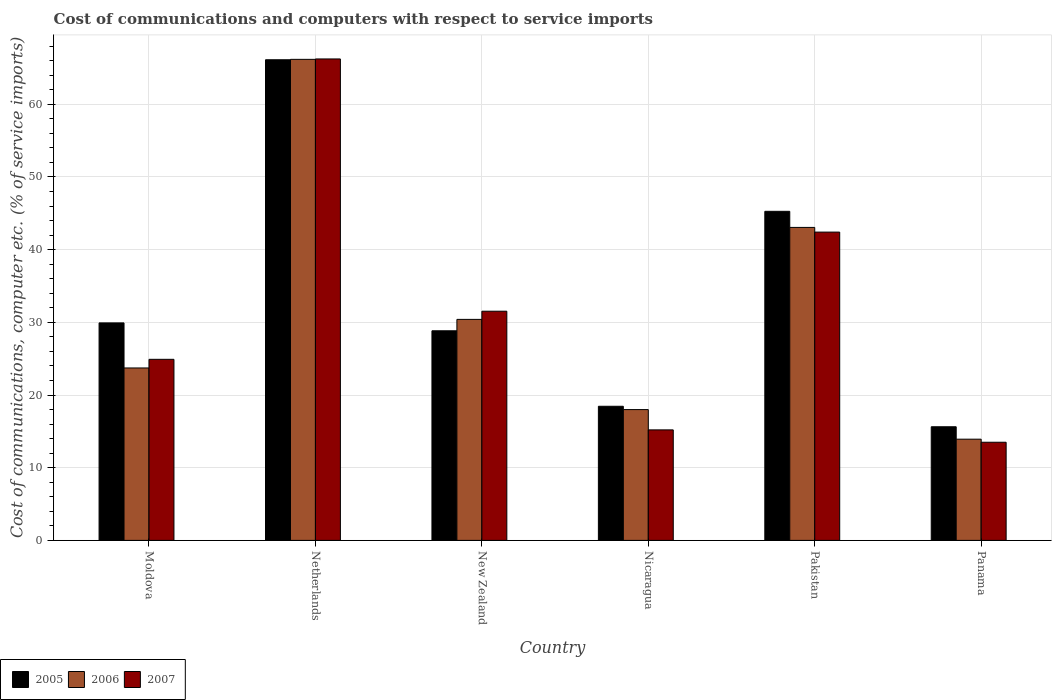Are the number of bars per tick equal to the number of legend labels?
Keep it short and to the point. Yes. Are the number of bars on each tick of the X-axis equal?
Give a very brief answer. Yes. How many bars are there on the 4th tick from the left?
Make the answer very short. 3. How many bars are there on the 4th tick from the right?
Your answer should be compact. 3. In how many cases, is the number of bars for a given country not equal to the number of legend labels?
Provide a short and direct response. 0. What is the cost of communications and computers in 2007 in Moldova?
Keep it short and to the point. 24.91. Across all countries, what is the maximum cost of communications and computers in 2005?
Ensure brevity in your answer.  66.12. Across all countries, what is the minimum cost of communications and computers in 2007?
Ensure brevity in your answer.  13.5. In which country was the cost of communications and computers in 2005 minimum?
Keep it short and to the point. Panama. What is the total cost of communications and computers in 2006 in the graph?
Give a very brief answer. 195.28. What is the difference between the cost of communications and computers in 2006 in Moldova and that in New Zealand?
Your response must be concise. -6.68. What is the difference between the cost of communications and computers in 2007 in New Zealand and the cost of communications and computers in 2006 in Moldova?
Offer a terse response. 7.81. What is the average cost of communications and computers in 2005 per country?
Keep it short and to the point. 34.04. What is the difference between the cost of communications and computers of/in 2005 and cost of communications and computers of/in 2007 in Nicaragua?
Offer a very short reply. 3.25. In how many countries, is the cost of communications and computers in 2005 greater than 38 %?
Ensure brevity in your answer.  2. What is the ratio of the cost of communications and computers in 2007 in Netherlands to that in New Zealand?
Your answer should be compact. 2.1. Is the cost of communications and computers in 2005 in New Zealand less than that in Nicaragua?
Your answer should be compact. No. Is the difference between the cost of communications and computers in 2005 in Netherlands and New Zealand greater than the difference between the cost of communications and computers in 2007 in Netherlands and New Zealand?
Offer a very short reply. Yes. What is the difference between the highest and the second highest cost of communications and computers in 2006?
Offer a terse response. 23.12. What is the difference between the highest and the lowest cost of communications and computers in 2007?
Offer a very short reply. 52.73. In how many countries, is the cost of communications and computers in 2005 greater than the average cost of communications and computers in 2005 taken over all countries?
Your answer should be compact. 2. What does the 1st bar from the right in New Zealand represents?
Your answer should be very brief. 2007. Is it the case that in every country, the sum of the cost of communications and computers in 2007 and cost of communications and computers in 2005 is greater than the cost of communications and computers in 2006?
Offer a terse response. Yes. How many bars are there?
Provide a short and direct response. 18. Are all the bars in the graph horizontal?
Your response must be concise. No. How many countries are there in the graph?
Your answer should be very brief. 6. What is the difference between two consecutive major ticks on the Y-axis?
Provide a succinct answer. 10. Does the graph contain any zero values?
Provide a succinct answer. No. Does the graph contain grids?
Make the answer very short. Yes. How many legend labels are there?
Make the answer very short. 3. What is the title of the graph?
Offer a very short reply. Cost of communications and computers with respect to service imports. Does "2007" appear as one of the legend labels in the graph?
Your response must be concise. Yes. What is the label or title of the Y-axis?
Provide a short and direct response. Cost of communications, computer etc. (% of service imports). What is the Cost of communications, computer etc. (% of service imports) in 2005 in Moldova?
Provide a succinct answer. 29.92. What is the Cost of communications, computer etc. (% of service imports) in 2006 in Moldova?
Your response must be concise. 23.72. What is the Cost of communications, computer etc. (% of service imports) in 2007 in Moldova?
Ensure brevity in your answer.  24.91. What is the Cost of communications, computer etc. (% of service imports) of 2005 in Netherlands?
Ensure brevity in your answer.  66.12. What is the Cost of communications, computer etc. (% of service imports) of 2006 in Netherlands?
Offer a terse response. 66.18. What is the Cost of communications, computer etc. (% of service imports) in 2007 in Netherlands?
Provide a succinct answer. 66.23. What is the Cost of communications, computer etc. (% of service imports) of 2005 in New Zealand?
Offer a very short reply. 28.84. What is the Cost of communications, computer etc. (% of service imports) of 2006 in New Zealand?
Make the answer very short. 30.4. What is the Cost of communications, computer etc. (% of service imports) of 2007 in New Zealand?
Provide a succinct answer. 31.53. What is the Cost of communications, computer etc. (% of service imports) of 2005 in Nicaragua?
Your response must be concise. 18.45. What is the Cost of communications, computer etc. (% of service imports) in 2006 in Nicaragua?
Your answer should be very brief. 18. What is the Cost of communications, computer etc. (% of service imports) of 2007 in Nicaragua?
Keep it short and to the point. 15.2. What is the Cost of communications, computer etc. (% of service imports) of 2005 in Pakistan?
Ensure brevity in your answer.  45.27. What is the Cost of communications, computer etc. (% of service imports) of 2006 in Pakistan?
Your response must be concise. 43.06. What is the Cost of communications, computer etc. (% of service imports) in 2007 in Pakistan?
Provide a succinct answer. 42.41. What is the Cost of communications, computer etc. (% of service imports) of 2005 in Panama?
Your answer should be compact. 15.63. What is the Cost of communications, computer etc. (% of service imports) in 2006 in Panama?
Provide a short and direct response. 13.92. What is the Cost of communications, computer etc. (% of service imports) in 2007 in Panama?
Offer a very short reply. 13.5. Across all countries, what is the maximum Cost of communications, computer etc. (% of service imports) in 2005?
Your answer should be very brief. 66.12. Across all countries, what is the maximum Cost of communications, computer etc. (% of service imports) of 2006?
Keep it short and to the point. 66.18. Across all countries, what is the maximum Cost of communications, computer etc. (% of service imports) in 2007?
Your response must be concise. 66.23. Across all countries, what is the minimum Cost of communications, computer etc. (% of service imports) of 2005?
Provide a short and direct response. 15.63. Across all countries, what is the minimum Cost of communications, computer etc. (% of service imports) in 2006?
Offer a terse response. 13.92. Across all countries, what is the minimum Cost of communications, computer etc. (% of service imports) in 2007?
Offer a very short reply. 13.5. What is the total Cost of communications, computer etc. (% of service imports) in 2005 in the graph?
Your response must be concise. 204.23. What is the total Cost of communications, computer etc. (% of service imports) of 2006 in the graph?
Your answer should be very brief. 195.28. What is the total Cost of communications, computer etc. (% of service imports) of 2007 in the graph?
Provide a short and direct response. 193.79. What is the difference between the Cost of communications, computer etc. (% of service imports) of 2005 in Moldova and that in Netherlands?
Give a very brief answer. -36.2. What is the difference between the Cost of communications, computer etc. (% of service imports) in 2006 in Moldova and that in Netherlands?
Provide a short and direct response. -42.46. What is the difference between the Cost of communications, computer etc. (% of service imports) in 2007 in Moldova and that in Netherlands?
Your answer should be compact. -41.32. What is the difference between the Cost of communications, computer etc. (% of service imports) of 2005 in Moldova and that in New Zealand?
Give a very brief answer. 1.08. What is the difference between the Cost of communications, computer etc. (% of service imports) of 2006 in Moldova and that in New Zealand?
Offer a very short reply. -6.68. What is the difference between the Cost of communications, computer etc. (% of service imports) in 2007 in Moldova and that in New Zealand?
Give a very brief answer. -6.62. What is the difference between the Cost of communications, computer etc. (% of service imports) of 2005 in Moldova and that in Nicaragua?
Offer a terse response. 11.47. What is the difference between the Cost of communications, computer etc. (% of service imports) in 2006 in Moldova and that in Nicaragua?
Offer a terse response. 5.73. What is the difference between the Cost of communications, computer etc. (% of service imports) of 2007 in Moldova and that in Nicaragua?
Provide a short and direct response. 9.71. What is the difference between the Cost of communications, computer etc. (% of service imports) of 2005 in Moldova and that in Pakistan?
Provide a short and direct response. -15.35. What is the difference between the Cost of communications, computer etc. (% of service imports) in 2006 in Moldova and that in Pakistan?
Ensure brevity in your answer.  -19.34. What is the difference between the Cost of communications, computer etc. (% of service imports) of 2007 in Moldova and that in Pakistan?
Make the answer very short. -17.5. What is the difference between the Cost of communications, computer etc. (% of service imports) of 2005 in Moldova and that in Panama?
Offer a very short reply. 14.29. What is the difference between the Cost of communications, computer etc. (% of service imports) of 2006 in Moldova and that in Panama?
Keep it short and to the point. 9.8. What is the difference between the Cost of communications, computer etc. (% of service imports) in 2007 in Moldova and that in Panama?
Your answer should be very brief. 11.41. What is the difference between the Cost of communications, computer etc. (% of service imports) in 2005 in Netherlands and that in New Zealand?
Your answer should be very brief. 37.29. What is the difference between the Cost of communications, computer etc. (% of service imports) of 2006 in Netherlands and that in New Zealand?
Your response must be concise. 35.77. What is the difference between the Cost of communications, computer etc. (% of service imports) of 2007 in Netherlands and that in New Zealand?
Your answer should be very brief. 34.7. What is the difference between the Cost of communications, computer etc. (% of service imports) of 2005 in Netherlands and that in Nicaragua?
Make the answer very short. 47.67. What is the difference between the Cost of communications, computer etc. (% of service imports) of 2006 in Netherlands and that in Nicaragua?
Offer a terse response. 48.18. What is the difference between the Cost of communications, computer etc. (% of service imports) in 2007 in Netherlands and that in Nicaragua?
Make the answer very short. 51.03. What is the difference between the Cost of communications, computer etc. (% of service imports) in 2005 in Netherlands and that in Pakistan?
Offer a very short reply. 20.85. What is the difference between the Cost of communications, computer etc. (% of service imports) in 2006 in Netherlands and that in Pakistan?
Ensure brevity in your answer.  23.12. What is the difference between the Cost of communications, computer etc. (% of service imports) of 2007 in Netherlands and that in Pakistan?
Your response must be concise. 23.82. What is the difference between the Cost of communications, computer etc. (% of service imports) in 2005 in Netherlands and that in Panama?
Offer a terse response. 50.49. What is the difference between the Cost of communications, computer etc. (% of service imports) in 2006 in Netherlands and that in Panama?
Your response must be concise. 52.25. What is the difference between the Cost of communications, computer etc. (% of service imports) of 2007 in Netherlands and that in Panama?
Give a very brief answer. 52.73. What is the difference between the Cost of communications, computer etc. (% of service imports) of 2005 in New Zealand and that in Nicaragua?
Provide a succinct answer. 10.38. What is the difference between the Cost of communications, computer etc. (% of service imports) of 2006 in New Zealand and that in Nicaragua?
Make the answer very short. 12.41. What is the difference between the Cost of communications, computer etc. (% of service imports) of 2007 in New Zealand and that in Nicaragua?
Make the answer very short. 16.32. What is the difference between the Cost of communications, computer etc. (% of service imports) of 2005 in New Zealand and that in Pakistan?
Provide a succinct answer. -16.43. What is the difference between the Cost of communications, computer etc. (% of service imports) in 2006 in New Zealand and that in Pakistan?
Offer a very short reply. -12.65. What is the difference between the Cost of communications, computer etc. (% of service imports) in 2007 in New Zealand and that in Pakistan?
Your answer should be compact. -10.88. What is the difference between the Cost of communications, computer etc. (% of service imports) in 2005 in New Zealand and that in Panama?
Make the answer very short. 13.2. What is the difference between the Cost of communications, computer etc. (% of service imports) of 2006 in New Zealand and that in Panama?
Provide a short and direct response. 16.48. What is the difference between the Cost of communications, computer etc. (% of service imports) of 2007 in New Zealand and that in Panama?
Offer a very short reply. 18.03. What is the difference between the Cost of communications, computer etc. (% of service imports) of 2005 in Nicaragua and that in Pakistan?
Your answer should be compact. -26.82. What is the difference between the Cost of communications, computer etc. (% of service imports) of 2006 in Nicaragua and that in Pakistan?
Your answer should be compact. -25.06. What is the difference between the Cost of communications, computer etc. (% of service imports) of 2007 in Nicaragua and that in Pakistan?
Provide a short and direct response. -27.21. What is the difference between the Cost of communications, computer etc. (% of service imports) of 2005 in Nicaragua and that in Panama?
Give a very brief answer. 2.82. What is the difference between the Cost of communications, computer etc. (% of service imports) in 2006 in Nicaragua and that in Panama?
Your response must be concise. 4.07. What is the difference between the Cost of communications, computer etc. (% of service imports) of 2007 in Nicaragua and that in Panama?
Your response must be concise. 1.7. What is the difference between the Cost of communications, computer etc. (% of service imports) of 2005 in Pakistan and that in Panama?
Offer a terse response. 29.64. What is the difference between the Cost of communications, computer etc. (% of service imports) in 2006 in Pakistan and that in Panama?
Ensure brevity in your answer.  29.13. What is the difference between the Cost of communications, computer etc. (% of service imports) in 2007 in Pakistan and that in Panama?
Make the answer very short. 28.91. What is the difference between the Cost of communications, computer etc. (% of service imports) of 2005 in Moldova and the Cost of communications, computer etc. (% of service imports) of 2006 in Netherlands?
Ensure brevity in your answer.  -36.26. What is the difference between the Cost of communications, computer etc. (% of service imports) in 2005 in Moldova and the Cost of communications, computer etc. (% of service imports) in 2007 in Netherlands?
Make the answer very short. -36.31. What is the difference between the Cost of communications, computer etc. (% of service imports) in 2006 in Moldova and the Cost of communications, computer etc. (% of service imports) in 2007 in Netherlands?
Give a very brief answer. -42.51. What is the difference between the Cost of communications, computer etc. (% of service imports) of 2005 in Moldova and the Cost of communications, computer etc. (% of service imports) of 2006 in New Zealand?
Offer a terse response. -0.48. What is the difference between the Cost of communications, computer etc. (% of service imports) in 2005 in Moldova and the Cost of communications, computer etc. (% of service imports) in 2007 in New Zealand?
Provide a succinct answer. -1.61. What is the difference between the Cost of communications, computer etc. (% of service imports) of 2006 in Moldova and the Cost of communications, computer etc. (% of service imports) of 2007 in New Zealand?
Your answer should be very brief. -7.81. What is the difference between the Cost of communications, computer etc. (% of service imports) of 2005 in Moldova and the Cost of communications, computer etc. (% of service imports) of 2006 in Nicaragua?
Keep it short and to the point. 11.93. What is the difference between the Cost of communications, computer etc. (% of service imports) in 2005 in Moldova and the Cost of communications, computer etc. (% of service imports) in 2007 in Nicaragua?
Ensure brevity in your answer.  14.72. What is the difference between the Cost of communications, computer etc. (% of service imports) of 2006 in Moldova and the Cost of communications, computer etc. (% of service imports) of 2007 in Nicaragua?
Offer a terse response. 8.52. What is the difference between the Cost of communications, computer etc. (% of service imports) of 2005 in Moldova and the Cost of communications, computer etc. (% of service imports) of 2006 in Pakistan?
Ensure brevity in your answer.  -13.14. What is the difference between the Cost of communications, computer etc. (% of service imports) of 2005 in Moldova and the Cost of communications, computer etc. (% of service imports) of 2007 in Pakistan?
Ensure brevity in your answer.  -12.49. What is the difference between the Cost of communications, computer etc. (% of service imports) in 2006 in Moldova and the Cost of communications, computer etc. (% of service imports) in 2007 in Pakistan?
Keep it short and to the point. -18.69. What is the difference between the Cost of communications, computer etc. (% of service imports) in 2005 in Moldova and the Cost of communications, computer etc. (% of service imports) in 2006 in Panama?
Offer a terse response. 16. What is the difference between the Cost of communications, computer etc. (% of service imports) of 2005 in Moldova and the Cost of communications, computer etc. (% of service imports) of 2007 in Panama?
Offer a terse response. 16.42. What is the difference between the Cost of communications, computer etc. (% of service imports) of 2006 in Moldova and the Cost of communications, computer etc. (% of service imports) of 2007 in Panama?
Give a very brief answer. 10.22. What is the difference between the Cost of communications, computer etc. (% of service imports) in 2005 in Netherlands and the Cost of communications, computer etc. (% of service imports) in 2006 in New Zealand?
Provide a short and direct response. 35.72. What is the difference between the Cost of communications, computer etc. (% of service imports) in 2005 in Netherlands and the Cost of communications, computer etc. (% of service imports) in 2007 in New Zealand?
Ensure brevity in your answer.  34.59. What is the difference between the Cost of communications, computer etc. (% of service imports) in 2006 in Netherlands and the Cost of communications, computer etc. (% of service imports) in 2007 in New Zealand?
Offer a terse response. 34.65. What is the difference between the Cost of communications, computer etc. (% of service imports) of 2005 in Netherlands and the Cost of communications, computer etc. (% of service imports) of 2006 in Nicaragua?
Offer a terse response. 48.13. What is the difference between the Cost of communications, computer etc. (% of service imports) in 2005 in Netherlands and the Cost of communications, computer etc. (% of service imports) in 2007 in Nicaragua?
Your answer should be compact. 50.92. What is the difference between the Cost of communications, computer etc. (% of service imports) of 2006 in Netherlands and the Cost of communications, computer etc. (% of service imports) of 2007 in Nicaragua?
Your answer should be very brief. 50.97. What is the difference between the Cost of communications, computer etc. (% of service imports) in 2005 in Netherlands and the Cost of communications, computer etc. (% of service imports) in 2006 in Pakistan?
Offer a terse response. 23.07. What is the difference between the Cost of communications, computer etc. (% of service imports) of 2005 in Netherlands and the Cost of communications, computer etc. (% of service imports) of 2007 in Pakistan?
Your answer should be compact. 23.71. What is the difference between the Cost of communications, computer etc. (% of service imports) of 2006 in Netherlands and the Cost of communications, computer etc. (% of service imports) of 2007 in Pakistan?
Provide a succinct answer. 23.77. What is the difference between the Cost of communications, computer etc. (% of service imports) of 2005 in Netherlands and the Cost of communications, computer etc. (% of service imports) of 2006 in Panama?
Provide a short and direct response. 52.2. What is the difference between the Cost of communications, computer etc. (% of service imports) of 2005 in Netherlands and the Cost of communications, computer etc. (% of service imports) of 2007 in Panama?
Give a very brief answer. 52.62. What is the difference between the Cost of communications, computer etc. (% of service imports) of 2006 in Netherlands and the Cost of communications, computer etc. (% of service imports) of 2007 in Panama?
Your answer should be very brief. 52.67. What is the difference between the Cost of communications, computer etc. (% of service imports) of 2005 in New Zealand and the Cost of communications, computer etc. (% of service imports) of 2006 in Nicaragua?
Keep it short and to the point. 10.84. What is the difference between the Cost of communications, computer etc. (% of service imports) in 2005 in New Zealand and the Cost of communications, computer etc. (% of service imports) in 2007 in Nicaragua?
Your response must be concise. 13.63. What is the difference between the Cost of communications, computer etc. (% of service imports) of 2006 in New Zealand and the Cost of communications, computer etc. (% of service imports) of 2007 in Nicaragua?
Your answer should be very brief. 15.2. What is the difference between the Cost of communications, computer etc. (% of service imports) of 2005 in New Zealand and the Cost of communications, computer etc. (% of service imports) of 2006 in Pakistan?
Give a very brief answer. -14.22. What is the difference between the Cost of communications, computer etc. (% of service imports) of 2005 in New Zealand and the Cost of communications, computer etc. (% of service imports) of 2007 in Pakistan?
Offer a terse response. -13.58. What is the difference between the Cost of communications, computer etc. (% of service imports) in 2006 in New Zealand and the Cost of communications, computer etc. (% of service imports) in 2007 in Pakistan?
Make the answer very short. -12.01. What is the difference between the Cost of communications, computer etc. (% of service imports) of 2005 in New Zealand and the Cost of communications, computer etc. (% of service imports) of 2006 in Panama?
Ensure brevity in your answer.  14.91. What is the difference between the Cost of communications, computer etc. (% of service imports) of 2005 in New Zealand and the Cost of communications, computer etc. (% of service imports) of 2007 in Panama?
Keep it short and to the point. 15.33. What is the difference between the Cost of communications, computer etc. (% of service imports) in 2006 in New Zealand and the Cost of communications, computer etc. (% of service imports) in 2007 in Panama?
Offer a very short reply. 16.9. What is the difference between the Cost of communications, computer etc. (% of service imports) of 2005 in Nicaragua and the Cost of communications, computer etc. (% of service imports) of 2006 in Pakistan?
Offer a very short reply. -24.61. What is the difference between the Cost of communications, computer etc. (% of service imports) in 2005 in Nicaragua and the Cost of communications, computer etc. (% of service imports) in 2007 in Pakistan?
Provide a succinct answer. -23.96. What is the difference between the Cost of communications, computer etc. (% of service imports) in 2006 in Nicaragua and the Cost of communications, computer etc. (% of service imports) in 2007 in Pakistan?
Offer a terse response. -24.42. What is the difference between the Cost of communications, computer etc. (% of service imports) in 2005 in Nicaragua and the Cost of communications, computer etc. (% of service imports) in 2006 in Panama?
Make the answer very short. 4.53. What is the difference between the Cost of communications, computer etc. (% of service imports) in 2005 in Nicaragua and the Cost of communications, computer etc. (% of service imports) in 2007 in Panama?
Ensure brevity in your answer.  4.95. What is the difference between the Cost of communications, computer etc. (% of service imports) in 2006 in Nicaragua and the Cost of communications, computer etc. (% of service imports) in 2007 in Panama?
Keep it short and to the point. 4.49. What is the difference between the Cost of communications, computer etc. (% of service imports) in 2005 in Pakistan and the Cost of communications, computer etc. (% of service imports) in 2006 in Panama?
Make the answer very short. 31.35. What is the difference between the Cost of communications, computer etc. (% of service imports) of 2005 in Pakistan and the Cost of communications, computer etc. (% of service imports) of 2007 in Panama?
Provide a short and direct response. 31.77. What is the difference between the Cost of communications, computer etc. (% of service imports) of 2006 in Pakistan and the Cost of communications, computer etc. (% of service imports) of 2007 in Panama?
Ensure brevity in your answer.  29.55. What is the average Cost of communications, computer etc. (% of service imports) of 2005 per country?
Ensure brevity in your answer.  34.04. What is the average Cost of communications, computer etc. (% of service imports) of 2006 per country?
Ensure brevity in your answer.  32.55. What is the average Cost of communications, computer etc. (% of service imports) of 2007 per country?
Make the answer very short. 32.3. What is the difference between the Cost of communications, computer etc. (% of service imports) in 2005 and Cost of communications, computer etc. (% of service imports) in 2007 in Moldova?
Provide a short and direct response. 5.01. What is the difference between the Cost of communications, computer etc. (% of service imports) in 2006 and Cost of communications, computer etc. (% of service imports) in 2007 in Moldova?
Provide a short and direct response. -1.19. What is the difference between the Cost of communications, computer etc. (% of service imports) of 2005 and Cost of communications, computer etc. (% of service imports) of 2006 in Netherlands?
Provide a short and direct response. -0.05. What is the difference between the Cost of communications, computer etc. (% of service imports) in 2005 and Cost of communications, computer etc. (% of service imports) in 2007 in Netherlands?
Your response must be concise. -0.11. What is the difference between the Cost of communications, computer etc. (% of service imports) in 2006 and Cost of communications, computer etc. (% of service imports) in 2007 in Netherlands?
Give a very brief answer. -0.06. What is the difference between the Cost of communications, computer etc. (% of service imports) of 2005 and Cost of communications, computer etc. (% of service imports) of 2006 in New Zealand?
Make the answer very short. -1.57. What is the difference between the Cost of communications, computer etc. (% of service imports) of 2005 and Cost of communications, computer etc. (% of service imports) of 2007 in New Zealand?
Give a very brief answer. -2.69. What is the difference between the Cost of communications, computer etc. (% of service imports) of 2006 and Cost of communications, computer etc. (% of service imports) of 2007 in New Zealand?
Your response must be concise. -1.12. What is the difference between the Cost of communications, computer etc. (% of service imports) in 2005 and Cost of communications, computer etc. (% of service imports) in 2006 in Nicaragua?
Your response must be concise. 0.46. What is the difference between the Cost of communications, computer etc. (% of service imports) of 2005 and Cost of communications, computer etc. (% of service imports) of 2007 in Nicaragua?
Keep it short and to the point. 3.25. What is the difference between the Cost of communications, computer etc. (% of service imports) of 2006 and Cost of communications, computer etc. (% of service imports) of 2007 in Nicaragua?
Offer a very short reply. 2.79. What is the difference between the Cost of communications, computer etc. (% of service imports) of 2005 and Cost of communications, computer etc. (% of service imports) of 2006 in Pakistan?
Give a very brief answer. 2.21. What is the difference between the Cost of communications, computer etc. (% of service imports) of 2005 and Cost of communications, computer etc. (% of service imports) of 2007 in Pakistan?
Provide a succinct answer. 2.86. What is the difference between the Cost of communications, computer etc. (% of service imports) in 2006 and Cost of communications, computer etc. (% of service imports) in 2007 in Pakistan?
Your answer should be very brief. 0.65. What is the difference between the Cost of communications, computer etc. (% of service imports) in 2005 and Cost of communications, computer etc. (% of service imports) in 2006 in Panama?
Your answer should be very brief. 1.71. What is the difference between the Cost of communications, computer etc. (% of service imports) in 2005 and Cost of communications, computer etc. (% of service imports) in 2007 in Panama?
Provide a short and direct response. 2.13. What is the difference between the Cost of communications, computer etc. (% of service imports) of 2006 and Cost of communications, computer etc. (% of service imports) of 2007 in Panama?
Your response must be concise. 0.42. What is the ratio of the Cost of communications, computer etc. (% of service imports) of 2005 in Moldova to that in Netherlands?
Give a very brief answer. 0.45. What is the ratio of the Cost of communications, computer etc. (% of service imports) of 2006 in Moldova to that in Netherlands?
Offer a very short reply. 0.36. What is the ratio of the Cost of communications, computer etc. (% of service imports) in 2007 in Moldova to that in Netherlands?
Keep it short and to the point. 0.38. What is the ratio of the Cost of communications, computer etc. (% of service imports) in 2005 in Moldova to that in New Zealand?
Provide a short and direct response. 1.04. What is the ratio of the Cost of communications, computer etc. (% of service imports) of 2006 in Moldova to that in New Zealand?
Give a very brief answer. 0.78. What is the ratio of the Cost of communications, computer etc. (% of service imports) of 2007 in Moldova to that in New Zealand?
Keep it short and to the point. 0.79. What is the ratio of the Cost of communications, computer etc. (% of service imports) in 2005 in Moldova to that in Nicaragua?
Your answer should be very brief. 1.62. What is the ratio of the Cost of communications, computer etc. (% of service imports) in 2006 in Moldova to that in Nicaragua?
Your answer should be very brief. 1.32. What is the ratio of the Cost of communications, computer etc. (% of service imports) of 2007 in Moldova to that in Nicaragua?
Offer a very short reply. 1.64. What is the ratio of the Cost of communications, computer etc. (% of service imports) in 2005 in Moldova to that in Pakistan?
Offer a very short reply. 0.66. What is the ratio of the Cost of communications, computer etc. (% of service imports) of 2006 in Moldova to that in Pakistan?
Make the answer very short. 0.55. What is the ratio of the Cost of communications, computer etc. (% of service imports) of 2007 in Moldova to that in Pakistan?
Provide a short and direct response. 0.59. What is the ratio of the Cost of communications, computer etc. (% of service imports) in 2005 in Moldova to that in Panama?
Provide a succinct answer. 1.91. What is the ratio of the Cost of communications, computer etc. (% of service imports) in 2006 in Moldova to that in Panama?
Offer a terse response. 1.7. What is the ratio of the Cost of communications, computer etc. (% of service imports) in 2007 in Moldova to that in Panama?
Your answer should be compact. 1.84. What is the ratio of the Cost of communications, computer etc. (% of service imports) in 2005 in Netherlands to that in New Zealand?
Provide a succinct answer. 2.29. What is the ratio of the Cost of communications, computer etc. (% of service imports) in 2006 in Netherlands to that in New Zealand?
Provide a short and direct response. 2.18. What is the ratio of the Cost of communications, computer etc. (% of service imports) of 2007 in Netherlands to that in New Zealand?
Your answer should be very brief. 2.1. What is the ratio of the Cost of communications, computer etc. (% of service imports) of 2005 in Netherlands to that in Nicaragua?
Offer a very short reply. 3.58. What is the ratio of the Cost of communications, computer etc. (% of service imports) of 2006 in Netherlands to that in Nicaragua?
Your response must be concise. 3.68. What is the ratio of the Cost of communications, computer etc. (% of service imports) in 2007 in Netherlands to that in Nicaragua?
Offer a terse response. 4.36. What is the ratio of the Cost of communications, computer etc. (% of service imports) in 2005 in Netherlands to that in Pakistan?
Your answer should be very brief. 1.46. What is the ratio of the Cost of communications, computer etc. (% of service imports) in 2006 in Netherlands to that in Pakistan?
Offer a terse response. 1.54. What is the ratio of the Cost of communications, computer etc. (% of service imports) of 2007 in Netherlands to that in Pakistan?
Keep it short and to the point. 1.56. What is the ratio of the Cost of communications, computer etc. (% of service imports) in 2005 in Netherlands to that in Panama?
Provide a succinct answer. 4.23. What is the ratio of the Cost of communications, computer etc. (% of service imports) in 2006 in Netherlands to that in Panama?
Your answer should be compact. 4.75. What is the ratio of the Cost of communications, computer etc. (% of service imports) of 2007 in Netherlands to that in Panama?
Give a very brief answer. 4.91. What is the ratio of the Cost of communications, computer etc. (% of service imports) of 2005 in New Zealand to that in Nicaragua?
Provide a short and direct response. 1.56. What is the ratio of the Cost of communications, computer etc. (% of service imports) in 2006 in New Zealand to that in Nicaragua?
Give a very brief answer. 1.69. What is the ratio of the Cost of communications, computer etc. (% of service imports) of 2007 in New Zealand to that in Nicaragua?
Ensure brevity in your answer.  2.07. What is the ratio of the Cost of communications, computer etc. (% of service imports) in 2005 in New Zealand to that in Pakistan?
Provide a short and direct response. 0.64. What is the ratio of the Cost of communications, computer etc. (% of service imports) of 2006 in New Zealand to that in Pakistan?
Offer a terse response. 0.71. What is the ratio of the Cost of communications, computer etc. (% of service imports) in 2007 in New Zealand to that in Pakistan?
Your answer should be very brief. 0.74. What is the ratio of the Cost of communications, computer etc. (% of service imports) of 2005 in New Zealand to that in Panama?
Your answer should be very brief. 1.84. What is the ratio of the Cost of communications, computer etc. (% of service imports) of 2006 in New Zealand to that in Panama?
Offer a very short reply. 2.18. What is the ratio of the Cost of communications, computer etc. (% of service imports) in 2007 in New Zealand to that in Panama?
Your answer should be very brief. 2.33. What is the ratio of the Cost of communications, computer etc. (% of service imports) in 2005 in Nicaragua to that in Pakistan?
Offer a very short reply. 0.41. What is the ratio of the Cost of communications, computer etc. (% of service imports) in 2006 in Nicaragua to that in Pakistan?
Provide a succinct answer. 0.42. What is the ratio of the Cost of communications, computer etc. (% of service imports) of 2007 in Nicaragua to that in Pakistan?
Offer a terse response. 0.36. What is the ratio of the Cost of communications, computer etc. (% of service imports) of 2005 in Nicaragua to that in Panama?
Ensure brevity in your answer.  1.18. What is the ratio of the Cost of communications, computer etc. (% of service imports) of 2006 in Nicaragua to that in Panama?
Offer a terse response. 1.29. What is the ratio of the Cost of communications, computer etc. (% of service imports) of 2007 in Nicaragua to that in Panama?
Provide a succinct answer. 1.13. What is the ratio of the Cost of communications, computer etc. (% of service imports) of 2005 in Pakistan to that in Panama?
Make the answer very short. 2.9. What is the ratio of the Cost of communications, computer etc. (% of service imports) of 2006 in Pakistan to that in Panama?
Your answer should be compact. 3.09. What is the ratio of the Cost of communications, computer etc. (% of service imports) of 2007 in Pakistan to that in Panama?
Make the answer very short. 3.14. What is the difference between the highest and the second highest Cost of communications, computer etc. (% of service imports) in 2005?
Your response must be concise. 20.85. What is the difference between the highest and the second highest Cost of communications, computer etc. (% of service imports) of 2006?
Provide a succinct answer. 23.12. What is the difference between the highest and the second highest Cost of communications, computer etc. (% of service imports) in 2007?
Your response must be concise. 23.82. What is the difference between the highest and the lowest Cost of communications, computer etc. (% of service imports) in 2005?
Ensure brevity in your answer.  50.49. What is the difference between the highest and the lowest Cost of communications, computer etc. (% of service imports) of 2006?
Make the answer very short. 52.25. What is the difference between the highest and the lowest Cost of communications, computer etc. (% of service imports) in 2007?
Offer a very short reply. 52.73. 